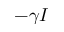<formula> <loc_0><loc_0><loc_500><loc_500>- \gamma I</formula> 